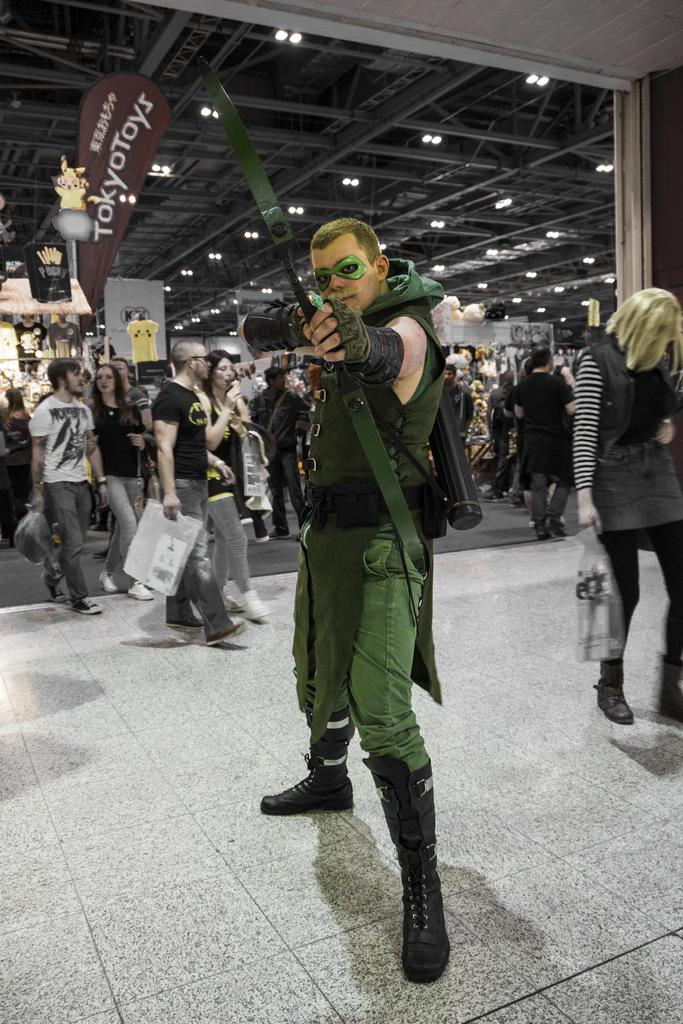What is the person in the image wearing? The person in the image is wearing a costume. What is the person in the costume doing? The person is standing. Can you describe the surroundings in the image? There are people in the background of the image, and there is a ceiling visible. What type of lighting is present in the image? There are lights in the image. What is hanging from the ceiling in the image? There is a banner in the image. What is written on the banner? There is text on the banner. What type of committee is overseeing the event in the image? There is no committee present in the image, nor is there any indication of an event taking place. 